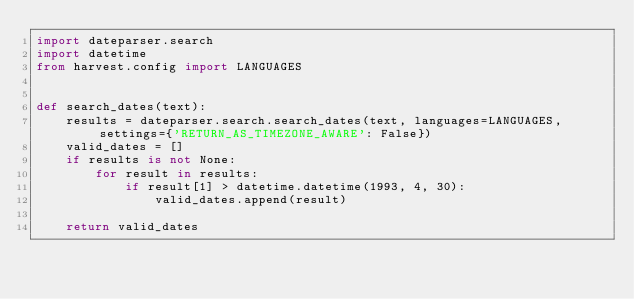Convert code to text. <code><loc_0><loc_0><loc_500><loc_500><_Python_>import dateparser.search
import datetime
from harvest.config import LANGUAGES


def search_dates(text):
    results = dateparser.search.search_dates(text, languages=LANGUAGES, settings={'RETURN_AS_TIMEZONE_AWARE': False})
    valid_dates = []
    if results is not None:
        for result in results:
            if result[1] > datetime.datetime(1993, 4, 30):
                valid_dates.append(result)

    return valid_dates
</code> 